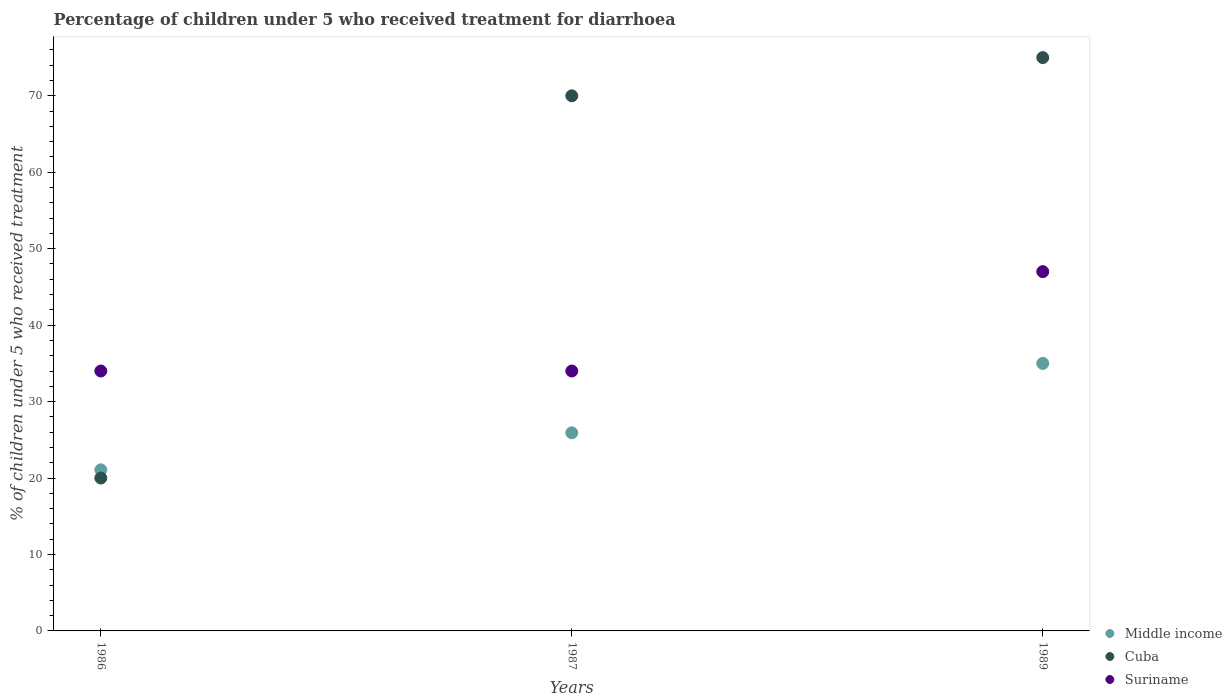How many different coloured dotlines are there?
Your answer should be very brief. 3. What is the percentage of children who received treatment for diarrhoea  in Suriname in 1987?
Ensure brevity in your answer.  34. Across all years, what is the minimum percentage of children who received treatment for diarrhoea  in Middle income?
Make the answer very short. 21.07. In which year was the percentage of children who received treatment for diarrhoea  in Cuba minimum?
Keep it short and to the point. 1986. What is the total percentage of children who received treatment for diarrhoea  in Cuba in the graph?
Ensure brevity in your answer.  165. What is the average percentage of children who received treatment for diarrhoea  in Suriname per year?
Your answer should be very brief. 38.33. In the year 1987, what is the difference between the percentage of children who received treatment for diarrhoea  in Middle income and percentage of children who received treatment for diarrhoea  in Cuba?
Provide a succinct answer. -44.08. In how many years, is the percentage of children who received treatment for diarrhoea  in Suriname greater than 36 %?
Your answer should be compact. 1. What is the ratio of the percentage of children who received treatment for diarrhoea  in Suriname in 1987 to that in 1989?
Offer a terse response. 0.72. Is the percentage of children who received treatment for diarrhoea  in Cuba in 1987 less than that in 1989?
Provide a succinct answer. Yes. What is the difference between the highest and the lowest percentage of children who received treatment for diarrhoea  in Middle income?
Provide a short and direct response. 13.92. Is the sum of the percentage of children who received treatment for diarrhoea  in Middle income in 1986 and 1989 greater than the maximum percentage of children who received treatment for diarrhoea  in Suriname across all years?
Your response must be concise. Yes. Is it the case that in every year, the sum of the percentage of children who received treatment for diarrhoea  in Cuba and percentage of children who received treatment for diarrhoea  in Suriname  is greater than the percentage of children who received treatment for diarrhoea  in Middle income?
Your response must be concise. Yes. Is the percentage of children who received treatment for diarrhoea  in Suriname strictly less than the percentage of children who received treatment for diarrhoea  in Cuba over the years?
Offer a very short reply. No. What is the difference between two consecutive major ticks on the Y-axis?
Your answer should be very brief. 10. Are the values on the major ticks of Y-axis written in scientific E-notation?
Your response must be concise. No. How many legend labels are there?
Provide a succinct answer. 3. What is the title of the graph?
Offer a terse response. Percentage of children under 5 who received treatment for diarrhoea. Does "Belarus" appear as one of the legend labels in the graph?
Your response must be concise. No. What is the label or title of the X-axis?
Your answer should be very brief. Years. What is the label or title of the Y-axis?
Your answer should be compact. % of children under 5 who received treatment. What is the % of children under 5 who received treatment in Middle income in 1986?
Ensure brevity in your answer.  21.07. What is the % of children under 5 who received treatment in Cuba in 1986?
Offer a very short reply. 20. What is the % of children under 5 who received treatment of Middle income in 1987?
Give a very brief answer. 25.92. What is the % of children under 5 who received treatment in Middle income in 1989?
Provide a succinct answer. 35. What is the % of children under 5 who received treatment of Suriname in 1989?
Make the answer very short. 47. Across all years, what is the maximum % of children under 5 who received treatment in Middle income?
Keep it short and to the point. 35. Across all years, what is the minimum % of children under 5 who received treatment of Middle income?
Offer a terse response. 21.07. Across all years, what is the minimum % of children under 5 who received treatment in Cuba?
Provide a short and direct response. 20. Across all years, what is the minimum % of children under 5 who received treatment of Suriname?
Provide a succinct answer. 34. What is the total % of children under 5 who received treatment of Middle income in the graph?
Ensure brevity in your answer.  81.99. What is the total % of children under 5 who received treatment of Cuba in the graph?
Offer a very short reply. 165. What is the total % of children under 5 who received treatment of Suriname in the graph?
Your response must be concise. 115. What is the difference between the % of children under 5 who received treatment of Middle income in 1986 and that in 1987?
Your response must be concise. -4.84. What is the difference between the % of children under 5 who received treatment of Cuba in 1986 and that in 1987?
Your answer should be compact. -50. What is the difference between the % of children under 5 who received treatment in Middle income in 1986 and that in 1989?
Your answer should be compact. -13.92. What is the difference between the % of children under 5 who received treatment in Cuba in 1986 and that in 1989?
Your answer should be very brief. -55. What is the difference between the % of children under 5 who received treatment in Suriname in 1986 and that in 1989?
Make the answer very short. -13. What is the difference between the % of children under 5 who received treatment of Middle income in 1987 and that in 1989?
Keep it short and to the point. -9.08. What is the difference between the % of children under 5 who received treatment of Cuba in 1987 and that in 1989?
Make the answer very short. -5. What is the difference between the % of children under 5 who received treatment of Suriname in 1987 and that in 1989?
Ensure brevity in your answer.  -13. What is the difference between the % of children under 5 who received treatment of Middle income in 1986 and the % of children under 5 who received treatment of Cuba in 1987?
Your response must be concise. -48.93. What is the difference between the % of children under 5 who received treatment in Middle income in 1986 and the % of children under 5 who received treatment in Suriname in 1987?
Keep it short and to the point. -12.93. What is the difference between the % of children under 5 who received treatment in Cuba in 1986 and the % of children under 5 who received treatment in Suriname in 1987?
Make the answer very short. -14. What is the difference between the % of children under 5 who received treatment in Middle income in 1986 and the % of children under 5 who received treatment in Cuba in 1989?
Give a very brief answer. -53.93. What is the difference between the % of children under 5 who received treatment in Middle income in 1986 and the % of children under 5 who received treatment in Suriname in 1989?
Provide a short and direct response. -25.93. What is the difference between the % of children under 5 who received treatment of Cuba in 1986 and the % of children under 5 who received treatment of Suriname in 1989?
Make the answer very short. -27. What is the difference between the % of children under 5 who received treatment in Middle income in 1987 and the % of children under 5 who received treatment in Cuba in 1989?
Make the answer very short. -49.08. What is the difference between the % of children under 5 who received treatment in Middle income in 1987 and the % of children under 5 who received treatment in Suriname in 1989?
Your answer should be very brief. -21.08. What is the average % of children under 5 who received treatment in Middle income per year?
Make the answer very short. 27.33. What is the average % of children under 5 who received treatment of Suriname per year?
Ensure brevity in your answer.  38.33. In the year 1986, what is the difference between the % of children under 5 who received treatment of Middle income and % of children under 5 who received treatment of Cuba?
Provide a short and direct response. 1.07. In the year 1986, what is the difference between the % of children under 5 who received treatment of Middle income and % of children under 5 who received treatment of Suriname?
Your response must be concise. -12.93. In the year 1987, what is the difference between the % of children under 5 who received treatment of Middle income and % of children under 5 who received treatment of Cuba?
Provide a short and direct response. -44.08. In the year 1987, what is the difference between the % of children under 5 who received treatment in Middle income and % of children under 5 who received treatment in Suriname?
Offer a very short reply. -8.08. In the year 1987, what is the difference between the % of children under 5 who received treatment of Cuba and % of children under 5 who received treatment of Suriname?
Your answer should be very brief. 36. In the year 1989, what is the difference between the % of children under 5 who received treatment in Middle income and % of children under 5 who received treatment in Cuba?
Offer a terse response. -40. In the year 1989, what is the difference between the % of children under 5 who received treatment in Middle income and % of children under 5 who received treatment in Suriname?
Offer a terse response. -12. In the year 1989, what is the difference between the % of children under 5 who received treatment in Cuba and % of children under 5 who received treatment in Suriname?
Your response must be concise. 28. What is the ratio of the % of children under 5 who received treatment in Middle income in 1986 to that in 1987?
Ensure brevity in your answer.  0.81. What is the ratio of the % of children under 5 who received treatment of Cuba in 1986 to that in 1987?
Your response must be concise. 0.29. What is the ratio of the % of children under 5 who received treatment in Middle income in 1986 to that in 1989?
Offer a very short reply. 0.6. What is the ratio of the % of children under 5 who received treatment in Cuba in 1986 to that in 1989?
Keep it short and to the point. 0.27. What is the ratio of the % of children under 5 who received treatment of Suriname in 1986 to that in 1989?
Provide a short and direct response. 0.72. What is the ratio of the % of children under 5 who received treatment of Middle income in 1987 to that in 1989?
Keep it short and to the point. 0.74. What is the ratio of the % of children under 5 who received treatment in Suriname in 1987 to that in 1989?
Your answer should be very brief. 0.72. What is the difference between the highest and the second highest % of children under 5 who received treatment of Middle income?
Offer a terse response. 9.08. What is the difference between the highest and the second highest % of children under 5 who received treatment of Cuba?
Your answer should be very brief. 5. What is the difference between the highest and the lowest % of children under 5 who received treatment in Middle income?
Your answer should be compact. 13.92. 